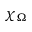<formula> <loc_0><loc_0><loc_500><loc_500>\chi _ { \Omega }</formula> 